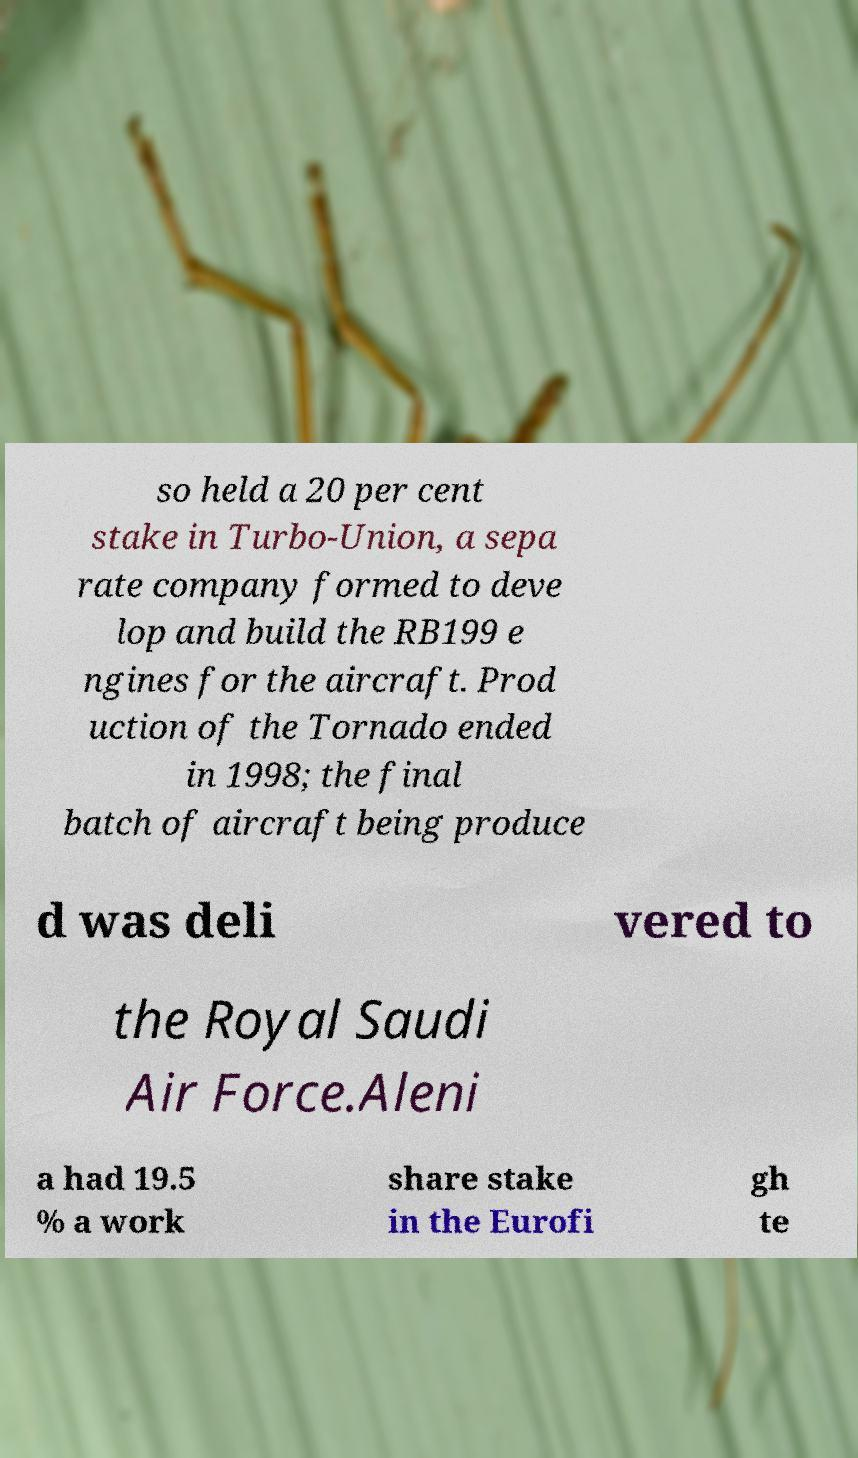Could you assist in decoding the text presented in this image and type it out clearly? so held a 20 per cent stake in Turbo-Union, a sepa rate company formed to deve lop and build the RB199 e ngines for the aircraft. Prod uction of the Tornado ended in 1998; the final batch of aircraft being produce d was deli vered to the Royal Saudi Air Force.Aleni a had 19.5 % a work share stake in the Eurofi gh te 